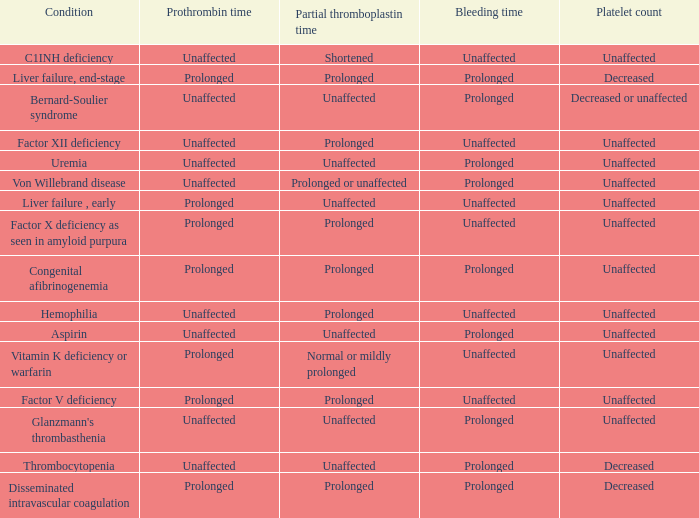Which Bleeding has a Condition of congenital afibrinogenemia? Prolonged. 